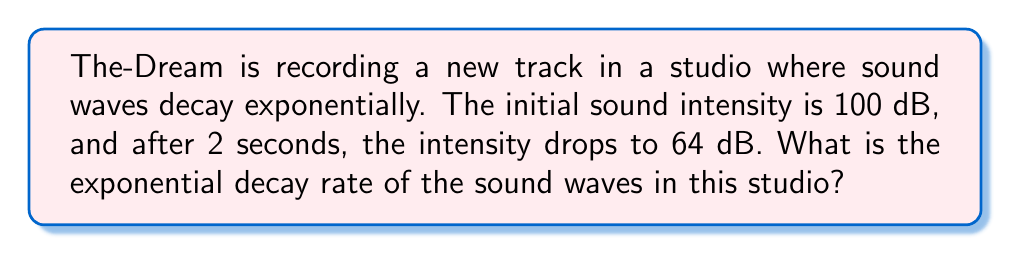Solve this math problem. Let's approach this step-by-step:

1) The general form of exponential decay is:
   $$A(t) = A_0 e^{-rt}$$
   where $A(t)$ is the amplitude at time $t$, $A_0$ is the initial amplitude, $r$ is the decay rate, and $t$ is time.

2) We're given:
   $A_0 = 100$ dB
   $A(2) = 64$ dB
   $t = 2$ seconds

3) Plugging these into our equation:
   $$64 = 100 e^{-2r}$$

4) Divide both sides by 100:
   $$0.64 = e^{-2r}$$

5) Take the natural log of both sides:
   $$\ln(0.64) = -2r$$

6) Solve for $r$:
   $$r = -\frac{\ln(0.64)}{2}$$

7) Calculate:
   $$r = -\frac{\ln(0.64)}{2} \approx 0.2231$$

Therefore, the exponential decay rate is approximately 0.2231 per second.
Answer: $0.2231$ $s^{-1}$ 